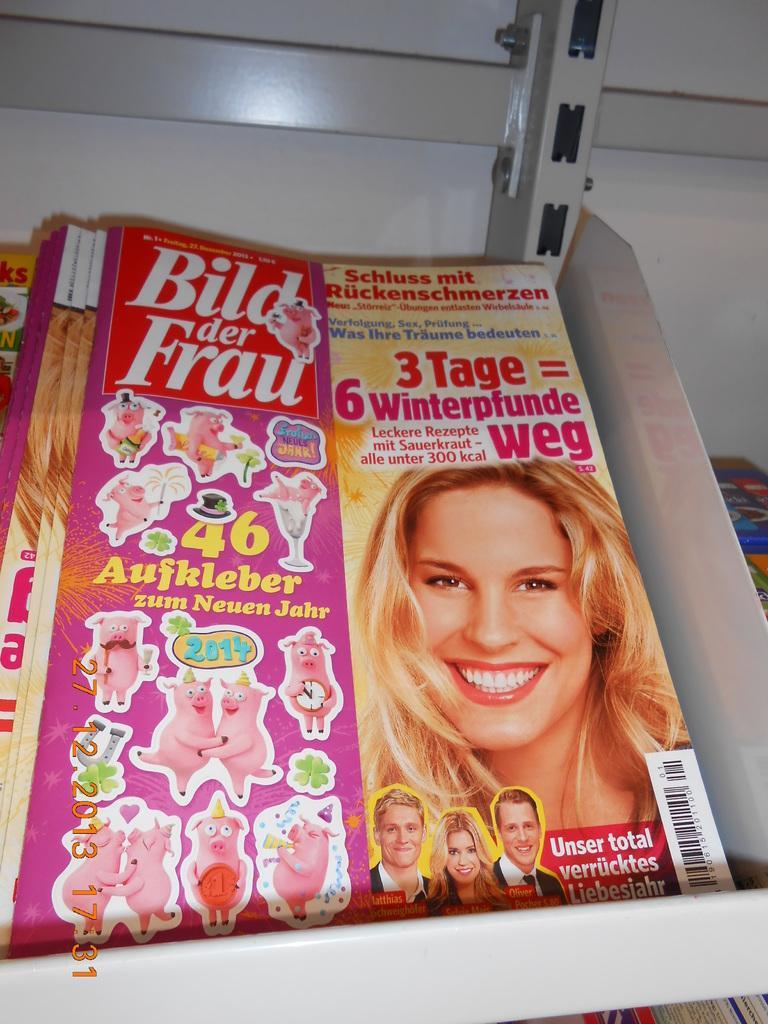How would you summarize this image in a sentence or two? The picture consists of iron racks and magazines. 